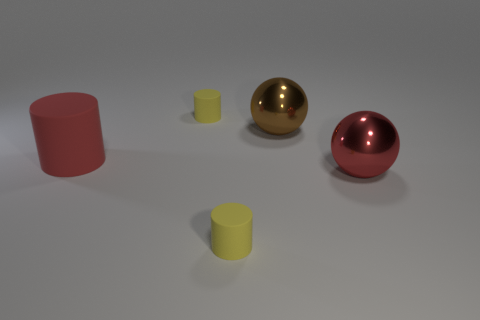Add 4 rubber cylinders. How many objects exist? 9 Subtract all cylinders. How many objects are left? 2 Add 2 large purple rubber spheres. How many large purple rubber spheres exist? 2 Subtract 0 cyan balls. How many objects are left? 5 Subtract all small rubber cylinders. Subtract all red shiny objects. How many objects are left? 2 Add 4 big red cylinders. How many big red cylinders are left? 5 